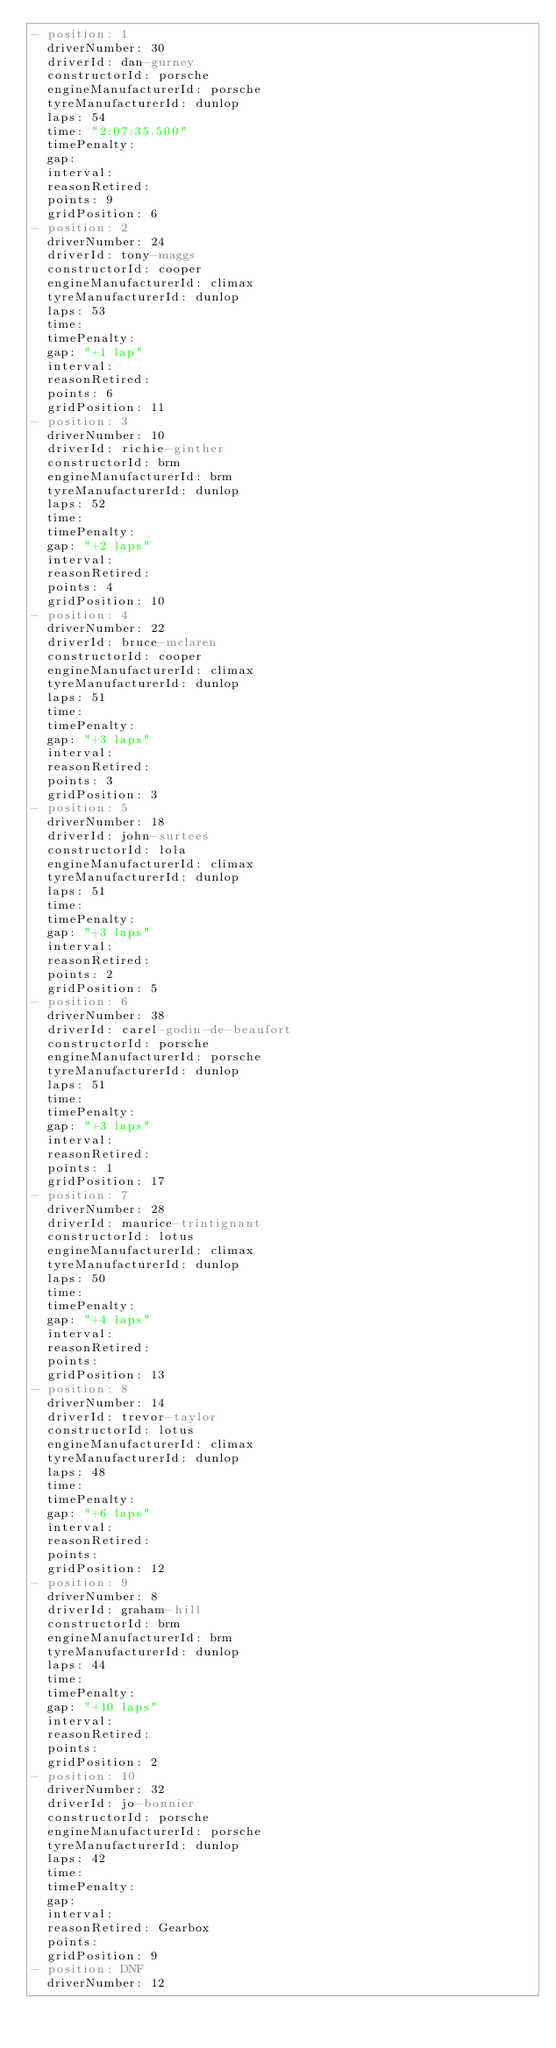Convert code to text. <code><loc_0><loc_0><loc_500><loc_500><_YAML_>- position: 1
  driverNumber: 30
  driverId: dan-gurney
  constructorId: porsche
  engineManufacturerId: porsche
  tyreManufacturerId: dunlop
  laps: 54
  time: "2:07:35.500"
  timePenalty:
  gap:
  interval:
  reasonRetired:
  points: 9
  gridPosition: 6
- position: 2
  driverNumber: 24
  driverId: tony-maggs
  constructorId: cooper
  engineManufacturerId: climax
  tyreManufacturerId: dunlop
  laps: 53
  time:
  timePenalty:
  gap: "+1 lap"
  interval:
  reasonRetired:
  points: 6
  gridPosition: 11
- position: 3
  driverNumber: 10
  driverId: richie-ginther
  constructorId: brm
  engineManufacturerId: brm
  tyreManufacturerId: dunlop
  laps: 52
  time:
  timePenalty:
  gap: "+2 laps"
  interval:
  reasonRetired:
  points: 4
  gridPosition: 10
- position: 4
  driverNumber: 22
  driverId: bruce-mclaren
  constructorId: cooper
  engineManufacturerId: climax
  tyreManufacturerId: dunlop
  laps: 51
  time:
  timePenalty:
  gap: "+3 laps"
  interval:
  reasonRetired:
  points: 3
  gridPosition: 3
- position: 5
  driverNumber: 18
  driverId: john-surtees
  constructorId: lola
  engineManufacturerId: climax
  tyreManufacturerId: dunlop
  laps: 51
  time:
  timePenalty:
  gap: "+3 laps"
  interval:
  reasonRetired:
  points: 2
  gridPosition: 5
- position: 6
  driverNumber: 38
  driverId: carel-godin-de-beaufort
  constructorId: porsche
  engineManufacturerId: porsche
  tyreManufacturerId: dunlop
  laps: 51
  time:
  timePenalty:
  gap: "+3 laps"
  interval:
  reasonRetired:
  points: 1
  gridPosition: 17
- position: 7
  driverNumber: 28
  driverId: maurice-trintignant
  constructorId: lotus
  engineManufacturerId: climax
  tyreManufacturerId: dunlop
  laps: 50
  time:
  timePenalty:
  gap: "+4 laps"
  interval:
  reasonRetired:
  points:
  gridPosition: 13
- position: 8
  driverNumber: 14
  driverId: trevor-taylor
  constructorId: lotus
  engineManufacturerId: climax
  tyreManufacturerId: dunlop
  laps: 48
  time:
  timePenalty:
  gap: "+6 laps"
  interval:
  reasonRetired:
  points:
  gridPosition: 12
- position: 9
  driverNumber: 8
  driverId: graham-hill
  constructorId: brm
  engineManufacturerId: brm
  tyreManufacturerId: dunlop
  laps: 44
  time:
  timePenalty:
  gap: "+10 laps"
  interval:
  reasonRetired:
  points:
  gridPosition: 2
- position: 10
  driverNumber: 32
  driverId: jo-bonnier
  constructorId: porsche
  engineManufacturerId: porsche
  tyreManufacturerId: dunlop
  laps: 42
  time:
  timePenalty:
  gap:
  interval:
  reasonRetired: Gearbox
  points:
  gridPosition: 9
- position: DNF
  driverNumber: 12</code> 